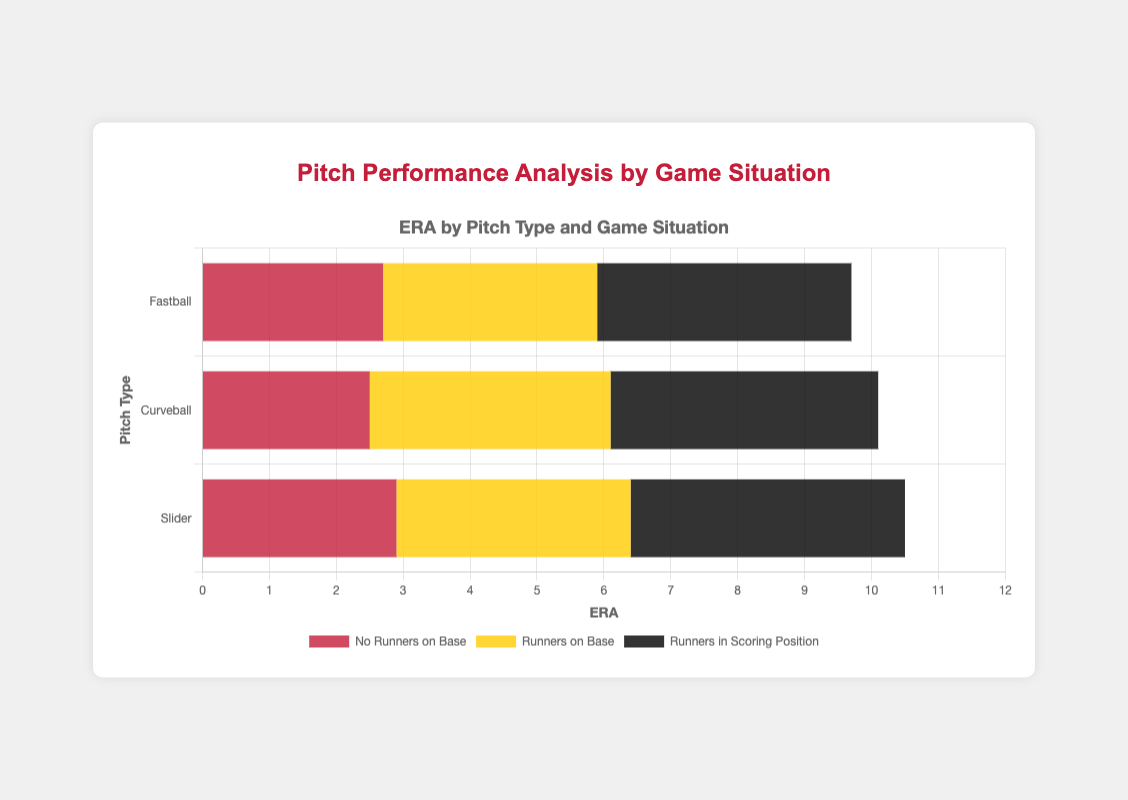What is the average ERA of Fastball and Curveball when there are runners in scoring position? To find the average ERA, sum the ERA values for Fastball (3.80) and Curveball (4.00) when there are runners in scoring position and divide by 2. (3.80 + 4.00) / 2 = 3.90
Answer: 3.90 Which pitch type has the highest ERA with runners on base? Compare the ERA values for Fastball (3.20), Curveball (3.60), and Slider (3.50) when there are runners on base. The highest ERA among these is Curveball's 3.60.
Answer: Curveball What is the total number of strikeouts for Fastball and Slider with no runners on base? Sum the strikeout values for Fastball (65) and Slider (60) when there are no runners on base. 65 + 60 = 125
Answer: 125 How does the ERA of Slider with runners in scoring position compare to Curveball with runners on base? Check the ERA of Slider with runners in scoring position (4.10) and Curveball with runners on base (3.60). Slider's ERA is higher.
Answer: Slider's ERA is higher What is the difference in ERA between Fastball and Slider with runners on base? Subtract the ERA of Fastball (3.20) from the ERA of Slider (3.50) with runners on base. 3.50 - 3.20 = 0.30
Answer: 0.30 Which pitch type has the lowest ERA with no runners on base? Compare the ERA values for Fastball (2.70), Curveball (2.50), and Slider (2.90) when there are no runners on base. The lowest ERA is Curveball's 2.50.
Answer: Curveball Visually, which pitch type has the longest bar for the 'Runners in Scoring Position' category? Observe the lengths of the bars for the 'Runners in Scoring Position' category. The bar for Curveball appears to be the longest, indicating the highest ERA.
Answer: Curveball What is the sum of innings pitched for all pitch types with runners in scoring position? Sum the innings pitched for Fastball (20), Curveball (18), and Slider (22) with runners in scoring position. 20 + 18 + 22 = 60
Answer: 60 